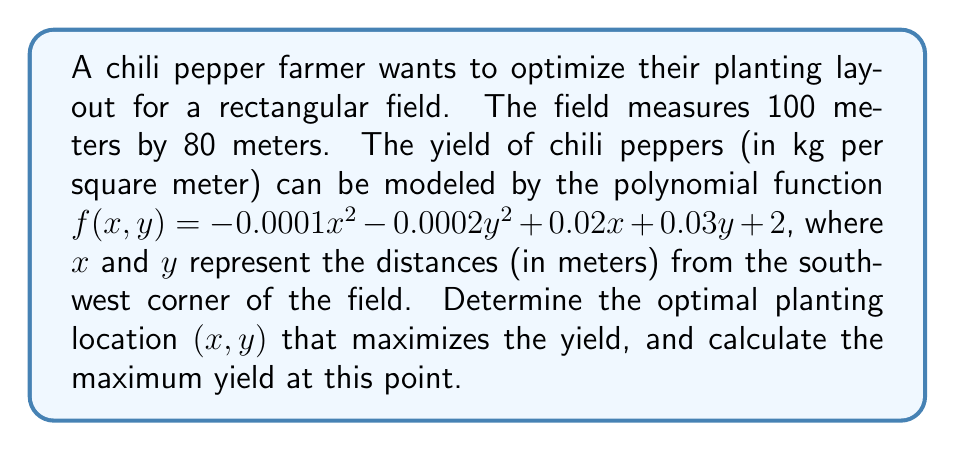Can you solve this math problem? To find the optimal planting location, we need to find the maximum value of the function $f(x, y)$ within the given field dimensions.

Step 1: Find the partial derivatives of $f(x, y)$ with respect to $x$ and $y$.
$$\frac{\partial f}{\partial x} = -0.0002x + 0.02$$
$$\frac{\partial f}{\partial y} = -0.0004y + 0.03$$

Step 2: Set both partial derivatives to zero to find the critical points.
$$-0.0002x + 0.02 = 0$$
$$-0.0004y + 0.03 = 0$$

Step 3: Solve for $x$ and $y$.
$$x = \frac{0.02}{0.0002} = 100$$
$$y = \frac{0.03}{0.0004} = 75$$

Step 4: Verify that the critical point $(100, 75)$ is within the field dimensions (100 m × 80 m).
The $x$-coordinate is at the edge of the field, but the $y$-coordinate exceeds the field's width. Therefore, we need to consider the boundaries.

Step 5: Evaluate $f(x, y)$ at the field's corners and edges:
- $f(0, 0) = 2$
- $f(100, 0) = 3$
- $f(0, 80) = 3.8$
- $f(100, 80) = 4.8$
- $f(100, y)$ (right edge): $f(100, y) = -0.0002y^2 + 0.03y + 4$
  Maximum at $y = 75$, but constrained to $y = 80$

Step 6: The maximum yield occurs at $(100, 80)$, the northeast corner of the field.

Step 7: Calculate the maximum yield:
$$f(100, 80) = -0.0001(100)^2 - 0.0002(80)^2 + 0.02(100) + 0.03(80) + 2 = 4.8$$
Answer: Optimal location: (100, 80); Maximum yield: 4.8 kg/m² 